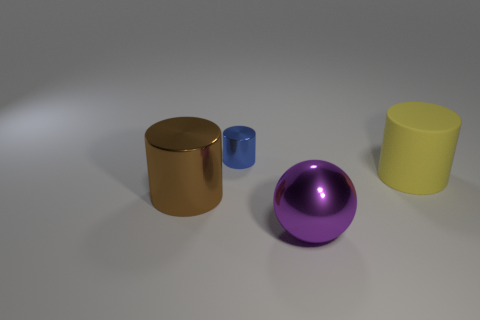Subtract all big yellow rubber cylinders. How many cylinders are left? 2 Add 1 tiny shiny cylinders. How many objects exist? 5 Subtract all yellow cylinders. How many cylinders are left? 2 Subtract 2 cylinders. How many cylinders are left? 1 Add 2 small blue cylinders. How many small blue cylinders are left? 3 Add 4 small metallic things. How many small metallic things exist? 5 Subtract 1 yellow cylinders. How many objects are left? 3 Subtract all cylinders. How many objects are left? 1 Subtract all brown cylinders. Subtract all brown balls. How many cylinders are left? 2 Subtract all blue metal cylinders. Subtract all large objects. How many objects are left? 0 